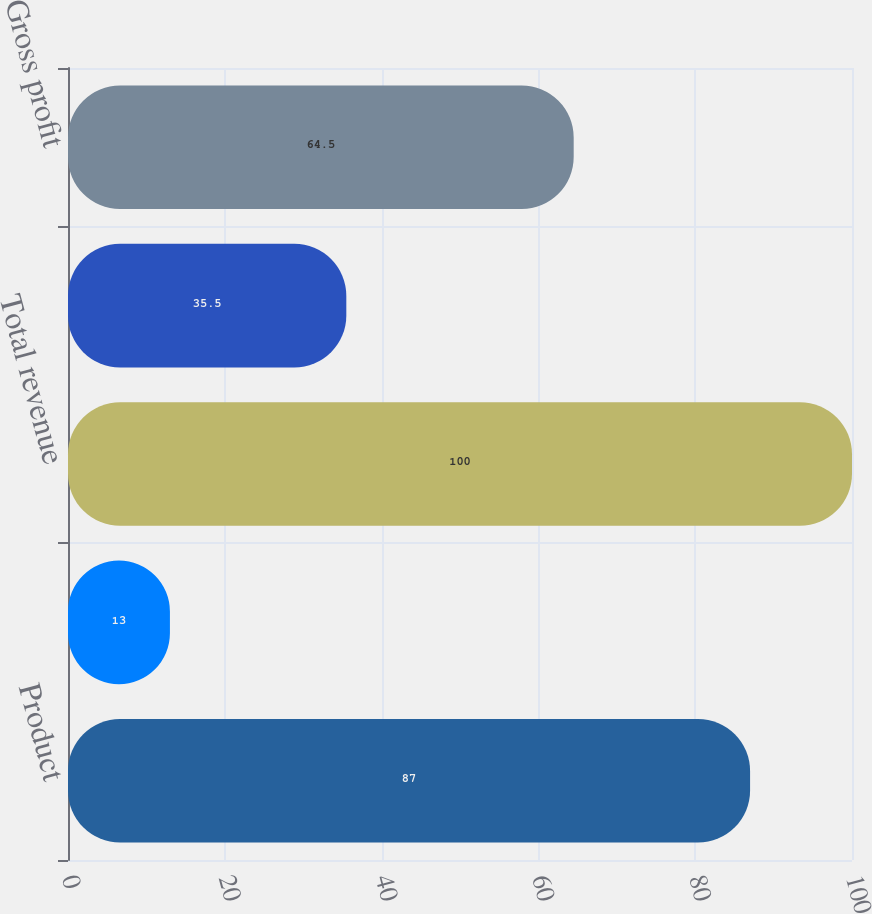Convert chart. <chart><loc_0><loc_0><loc_500><loc_500><bar_chart><fcel>Product<fcel>Service<fcel>Total revenue<fcel>Total cost of revenue<fcel>Gross profit<nl><fcel>87<fcel>13<fcel>100<fcel>35.5<fcel>64.5<nl></chart> 